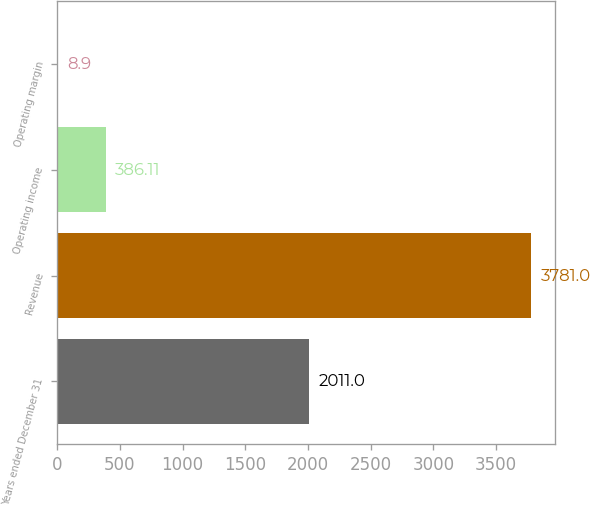<chart> <loc_0><loc_0><loc_500><loc_500><bar_chart><fcel>Years ended December 31<fcel>Revenue<fcel>Operating income<fcel>Operating margin<nl><fcel>2011<fcel>3781<fcel>386.11<fcel>8.9<nl></chart> 